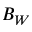Convert formula to latex. <formula><loc_0><loc_0><loc_500><loc_500>B _ { W }</formula> 